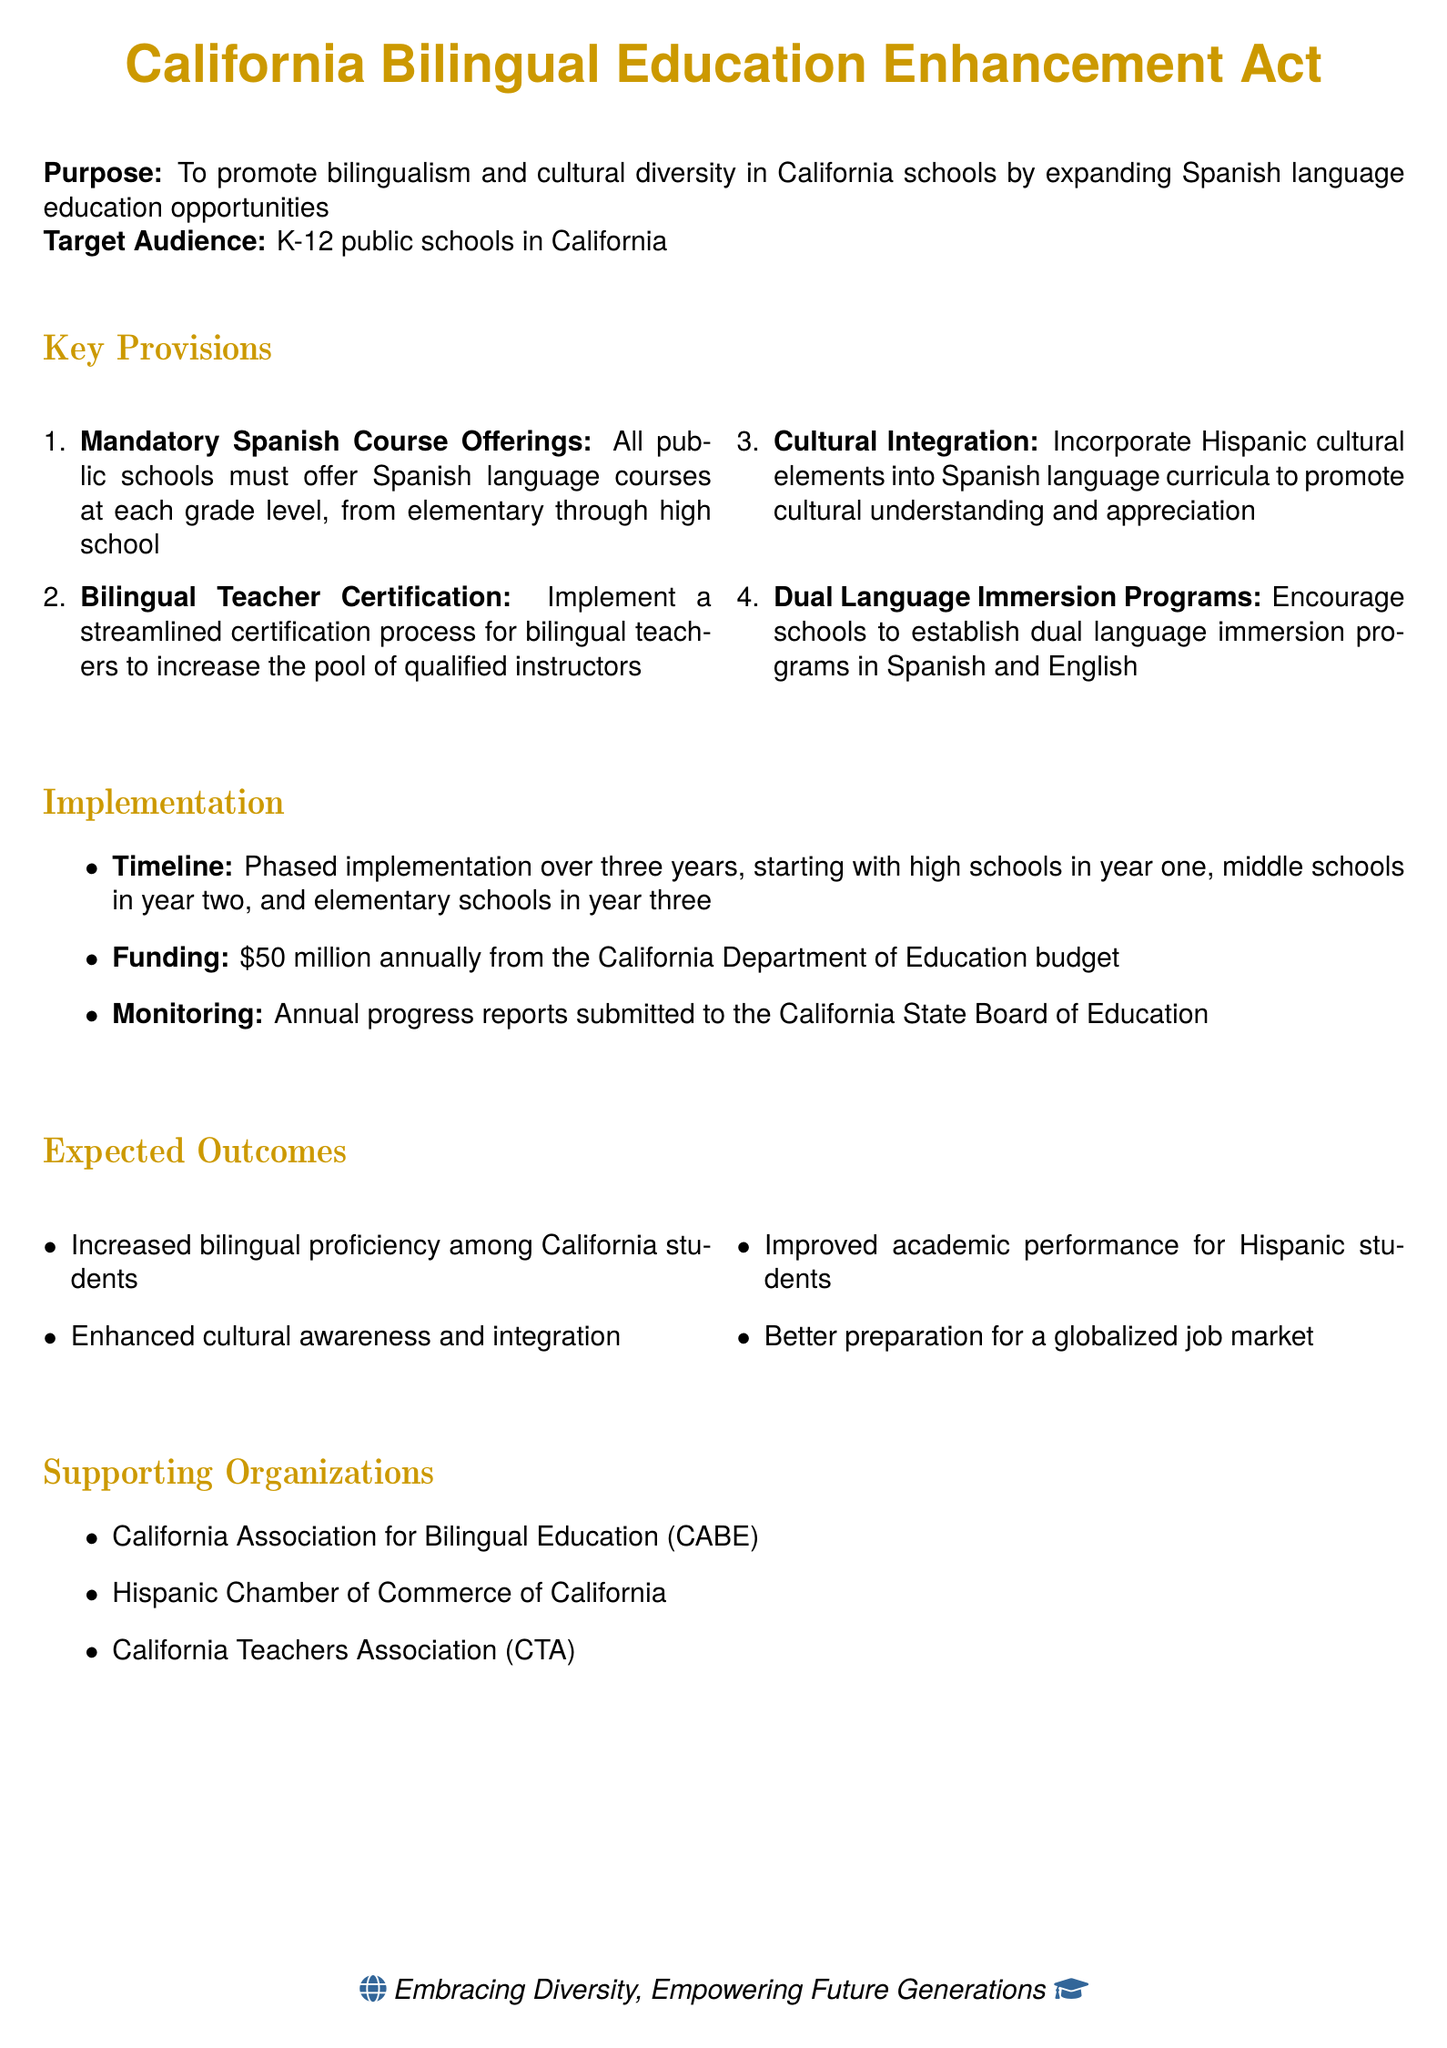What is the name of the act? The title of the act is stated clearly at the top of the document.
Answer: California Bilingual Education Enhancement Act What is the target audience of the policy? The document specifies the audience that would be affected by the policy.
Answer: K-12 public schools in California How much funding is allocated annually? The funding section mentions the specific amount allocated for the implementation of the policy.
Answer: 50 million dollars What is the implementation timeline starting with high schools? The timeline indicates the sequence of implementation for different school levels.
Answer: Three years Which organization supports bilingual education in California? The section on supporting organizations lists relevant associations and chambers that aid bilingual education.
Answer: California Association for Bilingual Education What are the required language courses for schools? The mandatory offerings are clearly outlined in the key provisions section.
Answer: Spanish language courses What will be incorporated into the Spanish curriculum? The document highlights what cultural elements should be included in the curriculum.
Answer: Hispanic cultural elements What is one expected outcome of the policy? The expected outcomes section details the benefits that the policy aims to achieve.
Answer: Increased bilingual proficiency What type of programs are schools encouraged to establish? The provisions suggest a specific type of program to foster bilingual education.
Answer: Dual language immersion programs 